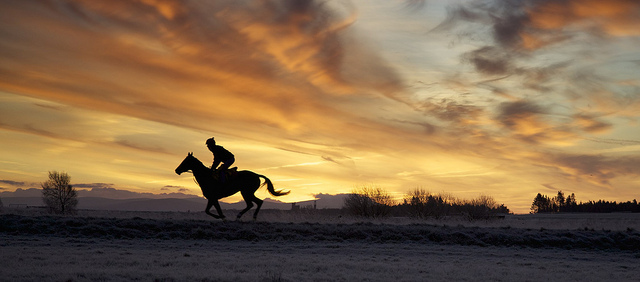Can you describe the activity taking place in this image? The image depicts a scene of equine motion, with a rider on horseback moving across the landscape, possibly engaging in a leisurely ride or exercising the horse. 